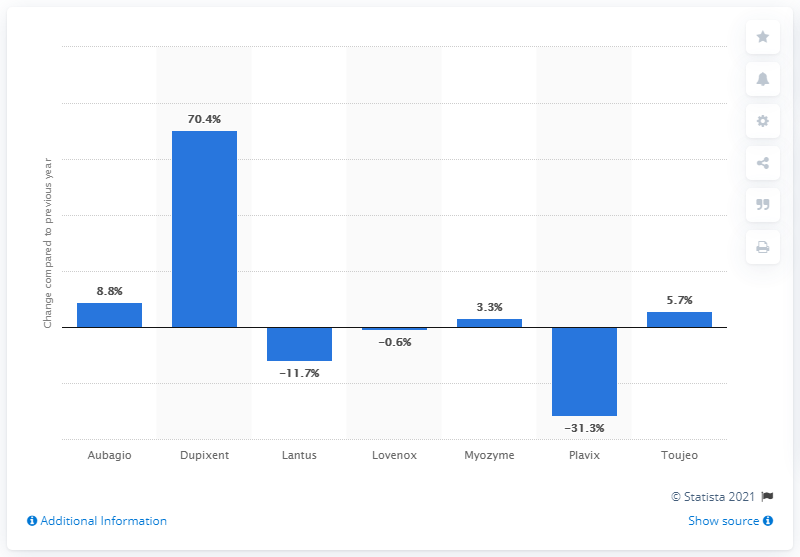Outline some significant characteristics in this image. Sanofi's best-selling pharmaceutical drugs showed varying growth rates. However, among these drugs, Dupixent exhibited the highest growth rate. 